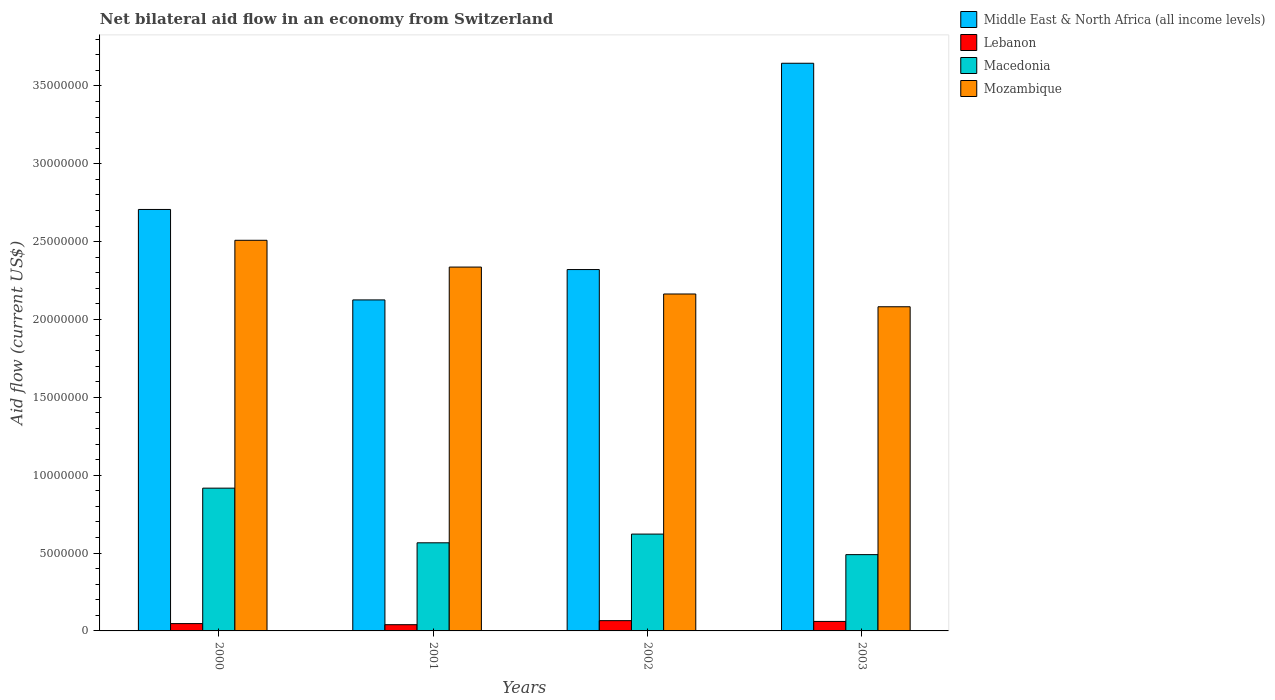How many different coloured bars are there?
Your answer should be very brief. 4. Are the number of bars per tick equal to the number of legend labels?
Give a very brief answer. Yes. How many bars are there on the 3rd tick from the left?
Your answer should be compact. 4. What is the label of the 4th group of bars from the left?
Make the answer very short. 2003. In how many cases, is the number of bars for a given year not equal to the number of legend labels?
Provide a short and direct response. 0. Across all years, what is the maximum net bilateral aid flow in Mozambique?
Offer a very short reply. 2.51e+07. Across all years, what is the minimum net bilateral aid flow in Mozambique?
Keep it short and to the point. 2.08e+07. What is the total net bilateral aid flow in Lebanon in the graph?
Offer a very short reply. 2.14e+06. What is the difference between the net bilateral aid flow in Mozambique in 2002 and that in 2003?
Your response must be concise. 8.20e+05. What is the difference between the net bilateral aid flow in Lebanon in 2000 and the net bilateral aid flow in Macedonia in 2003?
Your answer should be very brief. -4.43e+06. What is the average net bilateral aid flow in Mozambique per year?
Provide a succinct answer. 2.27e+07. In the year 2002, what is the difference between the net bilateral aid flow in Lebanon and net bilateral aid flow in Mozambique?
Give a very brief answer. -2.10e+07. In how many years, is the net bilateral aid flow in Middle East & North Africa (all income levels) greater than 20000000 US$?
Provide a succinct answer. 4. What is the ratio of the net bilateral aid flow in Mozambique in 2001 to that in 2002?
Your answer should be compact. 1.08. Is the net bilateral aid flow in Macedonia in 2002 less than that in 2003?
Provide a succinct answer. No. What is the difference between the highest and the lowest net bilateral aid flow in Macedonia?
Give a very brief answer. 4.27e+06. In how many years, is the net bilateral aid flow in Lebanon greater than the average net bilateral aid flow in Lebanon taken over all years?
Offer a very short reply. 2. Is the sum of the net bilateral aid flow in Macedonia in 2002 and 2003 greater than the maximum net bilateral aid flow in Lebanon across all years?
Ensure brevity in your answer.  Yes. Is it the case that in every year, the sum of the net bilateral aid flow in Lebanon and net bilateral aid flow in Mozambique is greater than the sum of net bilateral aid flow in Middle East & North Africa (all income levels) and net bilateral aid flow in Macedonia?
Provide a succinct answer. No. What does the 4th bar from the left in 2002 represents?
Your answer should be compact. Mozambique. What does the 3rd bar from the right in 2003 represents?
Offer a very short reply. Lebanon. Are all the bars in the graph horizontal?
Your answer should be compact. No. How many years are there in the graph?
Provide a short and direct response. 4. Does the graph contain grids?
Provide a succinct answer. No. How many legend labels are there?
Provide a short and direct response. 4. How are the legend labels stacked?
Provide a succinct answer. Vertical. What is the title of the graph?
Your answer should be very brief. Net bilateral aid flow in an economy from Switzerland. What is the Aid flow (current US$) in Middle East & North Africa (all income levels) in 2000?
Keep it short and to the point. 2.71e+07. What is the Aid flow (current US$) in Macedonia in 2000?
Ensure brevity in your answer.  9.17e+06. What is the Aid flow (current US$) of Mozambique in 2000?
Make the answer very short. 2.51e+07. What is the Aid flow (current US$) of Middle East & North Africa (all income levels) in 2001?
Your answer should be very brief. 2.13e+07. What is the Aid flow (current US$) in Lebanon in 2001?
Offer a terse response. 4.00e+05. What is the Aid flow (current US$) of Macedonia in 2001?
Your answer should be very brief. 5.66e+06. What is the Aid flow (current US$) of Mozambique in 2001?
Your response must be concise. 2.34e+07. What is the Aid flow (current US$) in Middle East & North Africa (all income levels) in 2002?
Give a very brief answer. 2.32e+07. What is the Aid flow (current US$) in Macedonia in 2002?
Your answer should be very brief. 6.22e+06. What is the Aid flow (current US$) of Mozambique in 2002?
Your response must be concise. 2.16e+07. What is the Aid flow (current US$) of Middle East & North Africa (all income levels) in 2003?
Your response must be concise. 3.65e+07. What is the Aid flow (current US$) in Macedonia in 2003?
Provide a succinct answer. 4.90e+06. What is the Aid flow (current US$) in Mozambique in 2003?
Offer a terse response. 2.08e+07. Across all years, what is the maximum Aid flow (current US$) in Middle East & North Africa (all income levels)?
Your answer should be very brief. 3.65e+07. Across all years, what is the maximum Aid flow (current US$) in Macedonia?
Provide a succinct answer. 9.17e+06. Across all years, what is the maximum Aid flow (current US$) of Mozambique?
Your response must be concise. 2.51e+07. Across all years, what is the minimum Aid flow (current US$) of Middle East & North Africa (all income levels)?
Make the answer very short. 2.13e+07. Across all years, what is the minimum Aid flow (current US$) in Macedonia?
Offer a very short reply. 4.90e+06. Across all years, what is the minimum Aid flow (current US$) in Mozambique?
Keep it short and to the point. 2.08e+07. What is the total Aid flow (current US$) of Middle East & North Africa (all income levels) in the graph?
Offer a terse response. 1.08e+08. What is the total Aid flow (current US$) of Lebanon in the graph?
Provide a short and direct response. 2.14e+06. What is the total Aid flow (current US$) in Macedonia in the graph?
Your response must be concise. 2.60e+07. What is the total Aid flow (current US$) in Mozambique in the graph?
Give a very brief answer. 9.09e+07. What is the difference between the Aid flow (current US$) of Middle East & North Africa (all income levels) in 2000 and that in 2001?
Ensure brevity in your answer.  5.81e+06. What is the difference between the Aid flow (current US$) of Macedonia in 2000 and that in 2001?
Your response must be concise. 3.51e+06. What is the difference between the Aid flow (current US$) in Mozambique in 2000 and that in 2001?
Your response must be concise. 1.72e+06. What is the difference between the Aid flow (current US$) of Middle East & North Africa (all income levels) in 2000 and that in 2002?
Ensure brevity in your answer.  3.86e+06. What is the difference between the Aid flow (current US$) in Lebanon in 2000 and that in 2002?
Give a very brief answer. -1.90e+05. What is the difference between the Aid flow (current US$) in Macedonia in 2000 and that in 2002?
Offer a very short reply. 2.95e+06. What is the difference between the Aid flow (current US$) of Mozambique in 2000 and that in 2002?
Make the answer very short. 3.45e+06. What is the difference between the Aid flow (current US$) of Middle East & North Africa (all income levels) in 2000 and that in 2003?
Provide a succinct answer. -9.39e+06. What is the difference between the Aid flow (current US$) of Lebanon in 2000 and that in 2003?
Provide a short and direct response. -1.40e+05. What is the difference between the Aid flow (current US$) of Macedonia in 2000 and that in 2003?
Your response must be concise. 4.27e+06. What is the difference between the Aid flow (current US$) in Mozambique in 2000 and that in 2003?
Your response must be concise. 4.27e+06. What is the difference between the Aid flow (current US$) of Middle East & North Africa (all income levels) in 2001 and that in 2002?
Your response must be concise. -1.95e+06. What is the difference between the Aid flow (current US$) of Lebanon in 2001 and that in 2002?
Your response must be concise. -2.60e+05. What is the difference between the Aid flow (current US$) of Macedonia in 2001 and that in 2002?
Offer a terse response. -5.60e+05. What is the difference between the Aid flow (current US$) in Mozambique in 2001 and that in 2002?
Your answer should be compact. 1.73e+06. What is the difference between the Aid flow (current US$) of Middle East & North Africa (all income levels) in 2001 and that in 2003?
Your response must be concise. -1.52e+07. What is the difference between the Aid flow (current US$) of Lebanon in 2001 and that in 2003?
Your response must be concise. -2.10e+05. What is the difference between the Aid flow (current US$) in Macedonia in 2001 and that in 2003?
Your answer should be compact. 7.60e+05. What is the difference between the Aid flow (current US$) in Mozambique in 2001 and that in 2003?
Ensure brevity in your answer.  2.55e+06. What is the difference between the Aid flow (current US$) of Middle East & North Africa (all income levels) in 2002 and that in 2003?
Make the answer very short. -1.32e+07. What is the difference between the Aid flow (current US$) in Macedonia in 2002 and that in 2003?
Your answer should be very brief. 1.32e+06. What is the difference between the Aid flow (current US$) of Mozambique in 2002 and that in 2003?
Provide a succinct answer. 8.20e+05. What is the difference between the Aid flow (current US$) of Middle East & North Africa (all income levels) in 2000 and the Aid flow (current US$) of Lebanon in 2001?
Offer a very short reply. 2.67e+07. What is the difference between the Aid flow (current US$) in Middle East & North Africa (all income levels) in 2000 and the Aid flow (current US$) in Macedonia in 2001?
Your answer should be compact. 2.14e+07. What is the difference between the Aid flow (current US$) of Middle East & North Africa (all income levels) in 2000 and the Aid flow (current US$) of Mozambique in 2001?
Keep it short and to the point. 3.70e+06. What is the difference between the Aid flow (current US$) in Lebanon in 2000 and the Aid flow (current US$) in Macedonia in 2001?
Keep it short and to the point. -5.19e+06. What is the difference between the Aid flow (current US$) in Lebanon in 2000 and the Aid flow (current US$) in Mozambique in 2001?
Provide a short and direct response. -2.29e+07. What is the difference between the Aid flow (current US$) of Macedonia in 2000 and the Aid flow (current US$) of Mozambique in 2001?
Provide a short and direct response. -1.42e+07. What is the difference between the Aid flow (current US$) of Middle East & North Africa (all income levels) in 2000 and the Aid flow (current US$) of Lebanon in 2002?
Offer a very short reply. 2.64e+07. What is the difference between the Aid flow (current US$) of Middle East & North Africa (all income levels) in 2000 and the Aid flow (current US$) of Macedonia in 2002?
Your answer should be very brief. 2.08e+07. What is the difference between the Aid flow (current US$) in Middle East & North Africa (all income levels) in 2000 and the Aid flow (current US$) in Mozambique in 2002?
Keep it short and to the point. 5.43e+06. What is the difference between the Aid flow (current US$) in Lebanon in 2000 and the Aid flow (current US$) in Macedonia in 2002?
Provide a succinct answer. -5.75e+06. What is the difference between the Aid flow (current US$) of Lebanon in 2000 and the Aid flow (current US$) of Mozambique in 2002?
Your answer should be very brief. -2.12e+07. What is the difference between the Aid flow (current US$) of Macedonia in 2000 and the Aid flow (current US$) of Mozambique in 2002?
Make the answer very short. -1.25e+07. What is the difference between the Aid flow (current US$) in Middle East & North Africa (all income levels) in 2000 and the Aid flow (current US$) in Lebanon in 2003?
Keep it short and to the point. 2.65e+07. What is the difference between the Aid flow (current US$) in Middle East & North Africa (all income levels) in 2000 and the Aid flow (current US$) in Macedonia in 2003?
Ensure brevity in your answer.  2.22e+07. What is the difference between the Aid flow (current US$) in Middle East & North Africa (all income levels) in 2000 and the Aid flow (current US$) in Mozambique in 2003?
Keep it short and to the point. 6.25e+06. What is the difference between the Aid flow (current US$) of Lebanon in 2000 and the Aid flow (current US$) of Macedonia in 2003?
Offer a very short reply. -4.43e+06. What is the difference between the Aid flow (current US$) of Lebanon in 2000 and the Aid flow (current US$) of Mozambique in 2003?
Give a very brief answer. -2.04e+07. What is the difference between the Aid flow (current US$) in Macedonia in 2000 and the Aid flow (current US$) in Mozambique in 2003?
Offer a very short reply. -1.16e+07. What is the difference between the Aid flow (current US$) of Middle East & North Africa (all income levels) in 2001 and the Aid flow (current US$) of Lebanon in 2002?
Provide a succinct answer. 2.06e+07. What is the difference between the Aid flow (current US$) in Middle East & North Africa (all income levels) in 2001 and the Aid flow (current US$) in Macedonia in 2002?
Keep it short and to the point. 1.50e+07. What is the difference between the Aid flow (current US$) in Middle East & North Africa (all income levels) in 2001 and the Aid flow (current US$) in Mozambique in 2002?
Your response must be concise. -3.80e+05. What is the difference between the Aid flow (current US$) in Lebanon in 2001 and the Aid flow (current US$) in Macedonia in 2002?
Make the answer very short. -5.82e+06. What is the difference between the Aid flow (current US$) of Lebanon in 2001 and the Aid flow (current US$) of Mozambique in 2002?
Offer a terse response. -2.12e+07. What is the difference between the Aid flow (current US$) of Macedonia in 2001 and the Aid flow (current US$) of Mozambique in 2002?
Offer a very short reply. -1.60e+07. What is the difference between the Aid flow (current US$) of Middle East & North Africa (all income levels) in 2001 and the Aid flow (current US$) of Lebanon in 2003?
Provide a short and direct response. 2.06e+07. What is the difference between the Aid flow (current US$) in Middle East & North Africa (all income levels) in 2001 and the Aid flow (current US$) in Macedonia in 2003?
Ensure brevity in your answer.  1.64e+07. What is the difference between the Aid flow (current US$) in Lebanon in 2001 and the Aid flow (current US$) in Macedonia in 2003?
Your answer should be compact. -4.50e+06. What is the difference between the Aid flow (current US$) of Lebanon in 2001 and the Aid flow (current US$) of Mozambique in 2003?
Ensure brevity in your answer.  -2.04e+07. What is the difference between the Aid flow (current US$) of Macedonia in 2001 and the Aid flow (current US$) of Mozambique in 2003?
Make the answer very short. -1.52e+07. What is the difference between the Aid flow (current US$) in Middle East & North Africa (all income levels) in 2002 and the Aid flow (current US$) in Lebanon in 2003?
Your response must be concise. 2.26e+07. What is the difference between the Aid flow (current US$) in Middle East & North Africa (all income levels) in 2002 and the Aid flow (current US$) in Macedonia in 2003?
Your response must be concise. 1.83e+07. What is the difference between the Aid flow (current US$) of Middle East & North Africa (all income levels) in 2002 and the Aid flow (current US$) of Mozambique in 2003?
Ensure brevity in your answer.  2.39e+06. What is the difference between the Aid flow (current US$) in Lebanon in 2002 and the Aid flow (current US$) in Macedonia in 2003?
Your answer should be very brief. -4.24e+06. What is the difference between the Aid flow (current US$) in Lebanon in 2002 and the Aid flow (current US$) in Mozambique in 2003?
Offer a terse response. -2.02e+07. What is the difference between the Aid flow (current US$) of Macedonia in 2002 and the Aid flow (current US$) of Mozambique in 2003?
Offer a terse response. -1.46e+07. What is the average Aid flow (current US$) in Middle East & North Africa (all income levels) per year?
Offer a terse response. 2.70e+07. What is the average Aid flow (current US$) in Lebanon per year?
Make the answer very short. 5.35e+05. What is the average Aid flow (current US$) in Macedonia per year?
Ensure brevity in your answer.  6.49e+06. What is the average Aid flow (current US$) in Mozambique per year?
Offer a terse response. 2.27e+07. In the year 2000, what is the difference between the Aid flow (current US$) of Middle East & North Africa (all income levels) and Aid flow (current US$) of Lebanon?
Your answer should be compact. 2.66e+07. In the year 2000, what is the difference between the Aid flow (current US$) in Middle East & North Africa (all income levels) and Aid flow (current US$) in Macedonia?
Offer a terse response. 1.79e+07. In the year 2000, what is the difference between the Aid flow (current US$) in Middle East & North Africa (all income levels) and Aid flow (current US$) in Mozambique?
Give a very brief answer. 1.98e+06. In the year 2000, what is the difference between the Aid flow (current US$) of Lebanon and Aid flow (current US$) of Macedonia?
Your answer should be compact. -8.70e+06. In the year 2000, what is the difference between the Aid flow (current US$) in Lebanon and Aid flow (current US$) in Mozambique?
Your answer should be compact. -2.46e+07. In the year 2000, what is the difference between the Aid flow (current US$) of Macedonia and Aid flow (current US$) of Mozambique?
Provide a short and direct response. -1.59e+07. In the year 2001, what is the difference between the Aid flow (current US$) in Middle East & North Africa (all income levels) and Aid flow (current US$) in Lebanon?
Offer a terse response. 2.09e+07. In the year 2001, what is the difference between the Aid flow (current US$) in Middle East & North Africa (all income levels) and Aid flow (current US$) in Macedonia?
Your response must be concise. 1.56e+07. In the year 2001, what is the difference between the Aid flow (current US$) of Middle East & North Africa (all income levels) and Aid flow (current US$) of Mozambique?
Provide a short and direct response. -2.11e+06. In the year 2001, what is the difference between the Aid flow (current US$) of Lebanon and Aid flow (current US$) of Macedonia?
Give a very brief answer. -5.26e+06. In the year 2001, what is the difference between the Aid flow (current US$) of Lebanon and Aid flow (current US$) of Mozambique?
Your response must be concise. -2.30e+07. In the year 2001, what is the difference between the Aid flow (current US$) of Macedonia and Aid flow (current US$) of Mozambique?
Provide a short and direct response. -1.77e+07. In the year 2002, what is the difference between the Aid flow (current US$) of Middle East & North Africa (all income levels) and Aid flow (current US$) of Lebanon?
Your answer should be compact. 2.26e+07. In the year 2002, what is the difference between the Aid flow (current US$) in Middle East & North Africa (all income levels) and Aid flow (current US$) in Macedonia?
Your answer should be compact. 1.70e+07. In the year 2002, what is the difference between the Aid flow (current US$) of Middle East & North Africa (all income levels) and Aid flow (current US$) of Mozambique?
Ensure brevity in your answer.  1.57e+06. In the year 2002, what is the difference between the Aid flow (current US$) in Lebanon and Aid flow (current US$) in Macedonia?
Provide a short and direct response. -5.56e+06. In the year 2002, what is the difference between the Aid flow (current US$) of Lebanon and Aid flow (current US$) of Mozambique?
Your answer should be very brief. -2.10e+07. In the year 2002, what is the difference between the Aid flow (current US$) in Macedonia and Aid flow (current US$) in Mozambique?
Provide a succinct answer. -1.54e+07. In the year 2003, what is the difference between the Aid flow (current US$) in Middle East & North Africa (all income levels) and Aid flow (current US$) in Lebanon?
Your answer should be compact. 3.58e+07. In the year 2003, what is the difference between the Aid flow (current US$) of Middle East & North Africa (all income levels) and Aid flow (current US$) of Macedonia?
Ensure brevity in your answer.  3.16e+07. In the year 2003, what is the difference between the Aid flow (current US$) in Middle East & North Africa (all income levels) and Aid flow (current US$) in Mozambique?
Give a very brief answer. 1.56e+07. In the year 2003, what is the difference between the Aid flow (current US$) in Lebanon and Aid flow (current US$) in Macedonia?
Ensure brevity in your answer.  -4.29e+06. In the year 2003, what is the difference between the Aid flow (current US$) of Lebanon and Aid flow (current US$) of Mozambique?
Offer a terse response. -2.02e+07. In the year 2003, what is the difference between the Aid flow (current US$) in Macedonia and Aid flow (current US$) in Mozambique?
Offer a very short reply. -1.59e+07. What is the ratio of the Aid flow (current US$) in Middle East & North Africa (all income levels) in 2000 to that in 2001?
Your answer should be very brief. 1.27. What is the ratio of the Aid flow (current US$) of Lebanon in 2000 to that in 2001?
Keep it short and to the point. 1.18. What is the ratio of the Aid flow (current US$) in Macedonia in 2000 to that in 2001?
Offer a very short reply. 1.62. What is the ratio of the Aid flow (current US$) in Mozambique in 2000 to that in 2001?
Make the answer very short. 1.07. What is the ratio of the Aid flow (current US$) of Middle East & North Africa (all income levels) in 2000 to that in 2002?
Provide a short and direct response. 1.17. What is the ratio of the Aid flow (current US$) in Lebanon in 2000 to that in 2002?
Provide a succinct answer. 0.71. What is the ratio of the Aid flow (current US$) in Macedonia in 2000 to that in 2002?
Ensure brevity in your answer.  1.47. What is the ratio of the Aid flow (current US$) in Mozambique in 2000 to that in 2002?
Your answer should be compact. 1.16. What is the ratio of the Aid flow (current US$) of Middle East & North Africa (all income levels) in 2000 to that in 2003?
Your response must be concise. 0.74. What is the ratio of the Aid flow (current US$) of Lebanon in 2000 to that in 2003?
Offer a terse response. 0.77. What is the ratio of the Aid flow (current US$) in Macedonia in 2000 to that in 2003?
Your answer should be very brief. 1.87. What is the ratio of the Aid flow (current US$) in Mozambique in 2000 to that in 2003?
Your answer should be very brief. 1.21. What is the ratio of the Aid flow (current US$) of Middle East & North Africa (all income levels) in 2001 to that in 2002?
Provide a short and direct response. 0.92. What is the ratio of the Aid flow (current US$) of Lebanon in 2001 to that in 2002?
Give a very brief answer. 0.61. What is the ratio of the Aid flow (current US$) of Macedonia in 2001 to that in 2002?
Your answer should be compact. 0.91. What is the ratio of the Aid flow (current US$) in Mozambique in 2001 to that in 2002?
Provide a short and direct response. 1.08. What is the ratio of the Aid flow (current US$) of Middle East & North Africa (all income levels) in 2001 to that in 2003?
Provide a succinct answer. 0.58. What is the ratio of the Aid flow (current US$) of Lebanon in 2001 to that in 2003?
Make the answer very short. 0.66. What is the ratio of the Aid flow (current US$) in Macedonia in 2001 to that in 2003?
Your answer should be very brief. 1.16. What is the ratio of the Aid flow (current US$) in Mozambique in 2001 to that in 2003?
Make the answer very short. 1.12. What is the ratio of the Aid flow (current US$) of Middle East & North Africa (all income levels) in 2002 to that in 2003?
Your answer should be compact. 0.64. What is the ratio of the Aid flow (current US$) of Lebanon in 2002 to that in 2003?
Offer a very short reply. 1.08. What is the ratio of the Aid flow (current US$) of Macedonia in 2002 to that in 2003?
Your answer should be very brief. 1.27. What is the ratio of the Aid flow (current US$) of Mozambique in 2002 to that in 2003?
Offer a very short reply. 1.04. What is the difference between the highest and the second highest Aid flow (current US$) in Middle East & North Africa (all income levels)?
Your answer should be very brief. 9.39e+06. What is the difference between the highest and the second highest Aid flow (current US$) in Lebanon?
Make the answer very short. 5.00e+04. What is the difference between the highest and the second highest Aid flow (current US$) in Macedonia?
Keep it short and to the point. 2.95e+06. What is the difference between the highest and the second highest Aid flow (current US$) of Mozambique?
Your answer should be very brief. 1.72e+06. What is the difference between the highest and the lowest Aid flow (current US$) in Middle East & North Africa (all income levels)?
Provide a succinct answer. 1.52e+07. What is the difference between the highest and the lowest Aid flow (current US$) of Lebanon?
Offer a very short reply. 2.60e+05. What is the difference between the highest and the lowest Aid flow (current US$) of Macedonia?
Offer a very short reply. 4.27e+06. What is the difference between the highest and the lowest Aid flow (current US$) in Mozambique?
Provide a succinct answer. 4.27e+06. 